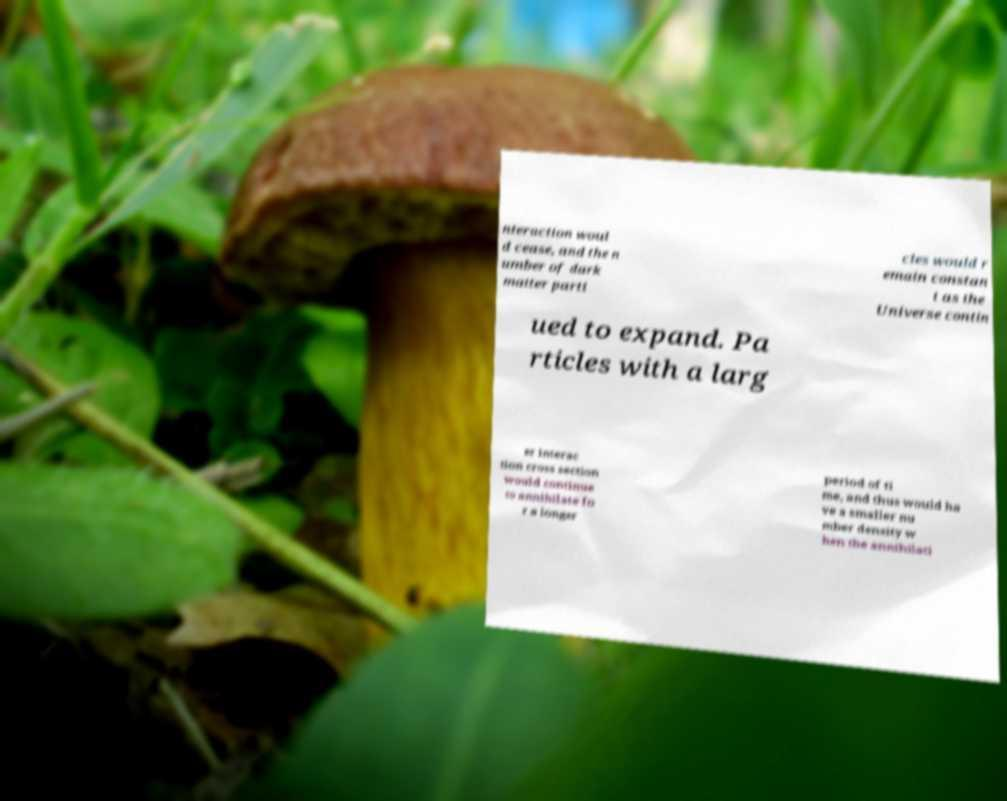Can you read and provide the text displayed in the image?This photo seems to have some interesting text. Can you extract and type it out for me? nteraction woul d cease, and the n umber of dark matter parti cles would r emain constan t as the Universe contin ued to expand. Pa rticles with a larg er interac tion cross section would continue to annihilate fo r a longer period of ti me, and thus would ha ve a smaller nu mber density w hen the annihilati 